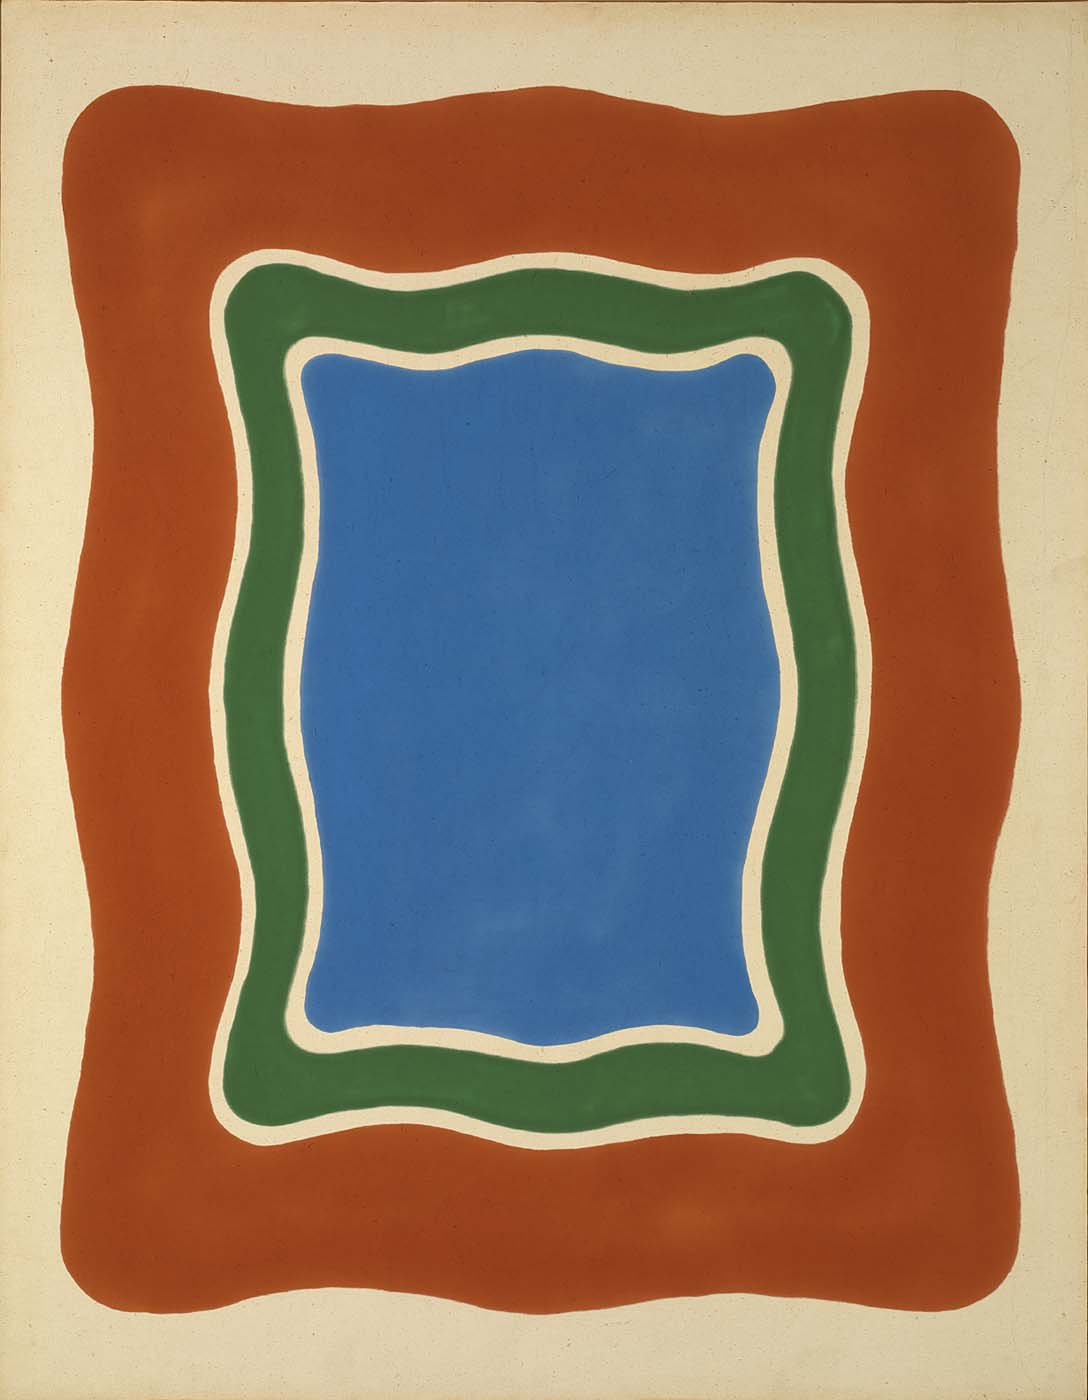Do you think this piece could symbolize anything? This artwork might symbolize the balance between order and chaos, with the blue rectangle representing stability and serenity, and the surrounding organic, curvy shapes embodying the unpredictability and movement of life. The contrast in colors and forms could reflect the duality of existence, the interplay between structured and unstructured elements, and the harmony that can be found within that tension. 